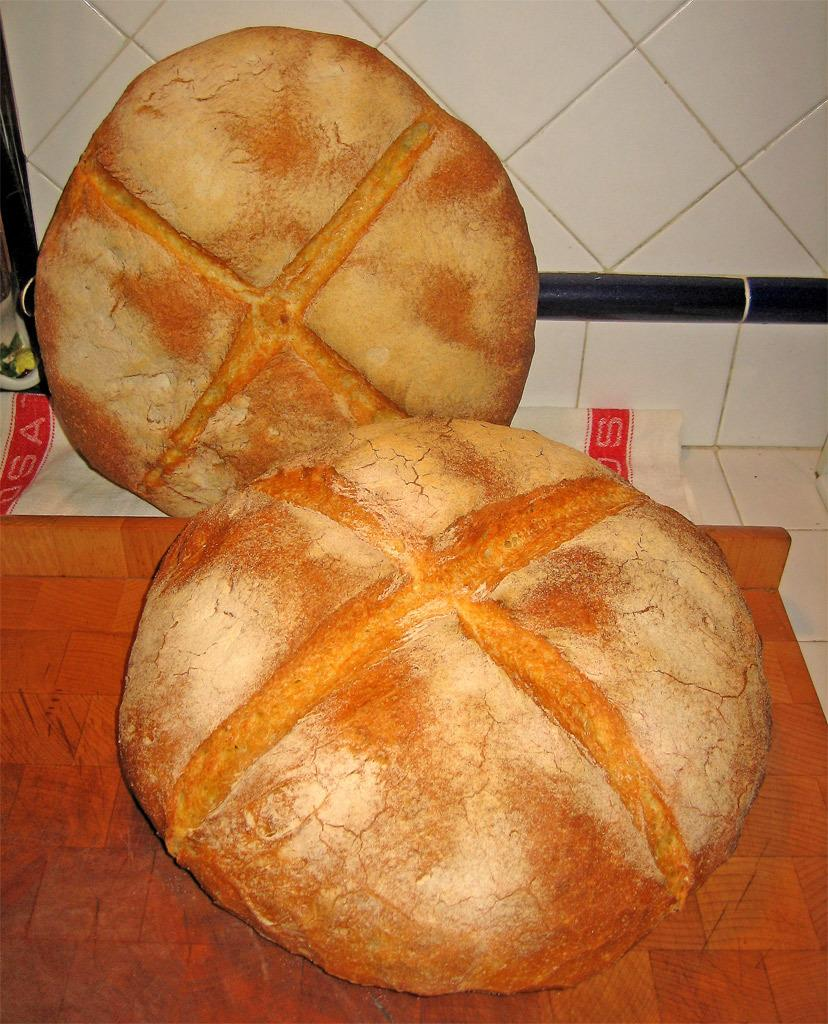What is on the table in the image? There are fruits on a table in the image. What can be seen behind the fruits on the table? There is a wall visible behind the fruits. What sound can be heard coming from the calculator in the image? There is no calculator present in the image, so no sound can be heard from it. 